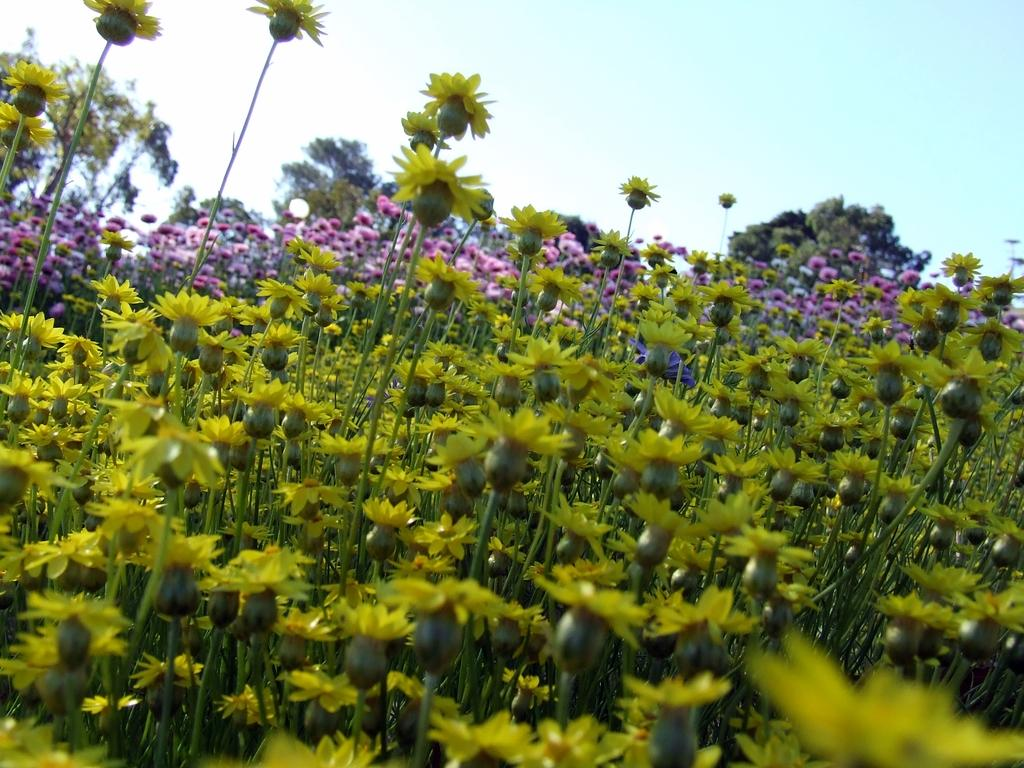What type of vegetation can be seen in the image? There are trees in the image. What is the color of the trees in the image? The trees are green in color. What other type of plant life is visible in the image? There are flowers in the image. What colors are the flowers in the image? The flowers are yellow and pink in color. What is visible in the background of the image? There are trees and the sky visible in the background of the image. What type of treatment is being administered to the carpenter in the image? There is no carpenter present in the image, and therefore no treatment can be observed. What type of berry can be seen growing on the trees in the image? There is no mention of berries in the image; the trees are described as having green leaves. 